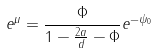<formula> <loc_0><loc_0><loc_500><loc_500>e ^ { \mu } = \frac { \Phi } { 1 - \frac { 2 a } { d } - \Phi } e ^ { - \psi _ { 0 } }</formula> 